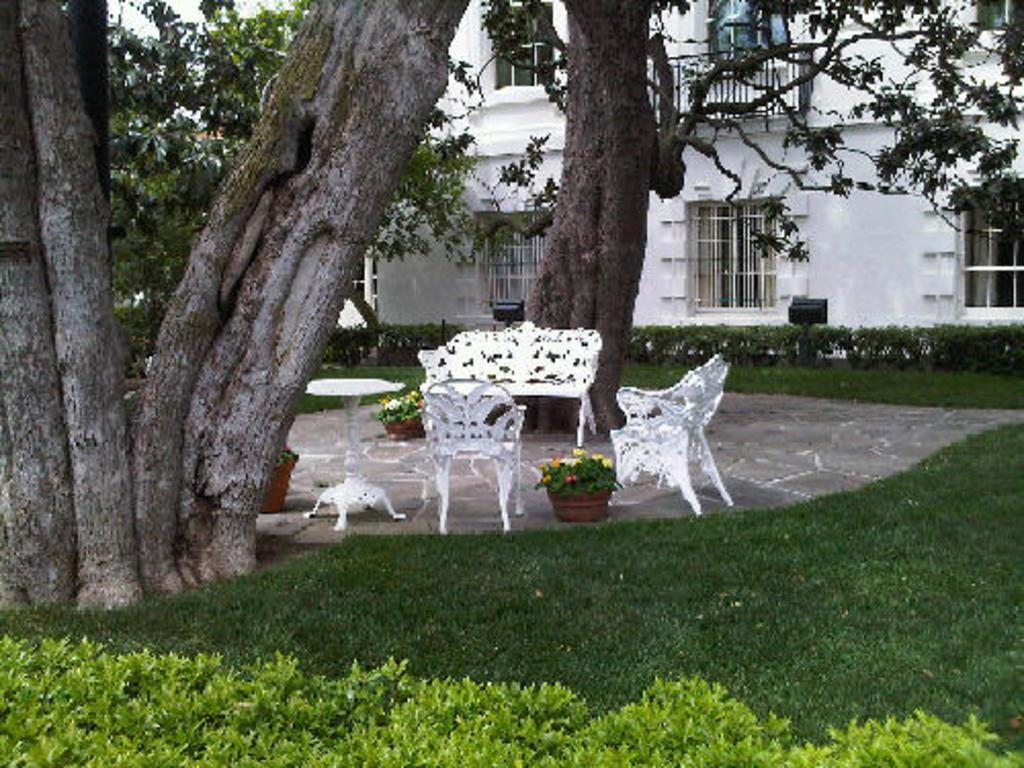What type of ground is visible in the image? There is grass ground in the image. What color are the chairs in the image? The chairs in the image are white. What furniture is present in the image? There is a table and a bench in the image. What type of vegetation can be seen in the image? There are plants and trees in the image. What type of structure is visible in the image? There is a white color building in the image. What architectural feature can be seen in the building? There are windows in the image. Can you see any icicles hanging from the trees in the image? There are no icicles present in the image; it appears to be a warm and sunny day. What type of motion is depicted in the image? There is no motion depicted in the image; it is a still scene. 